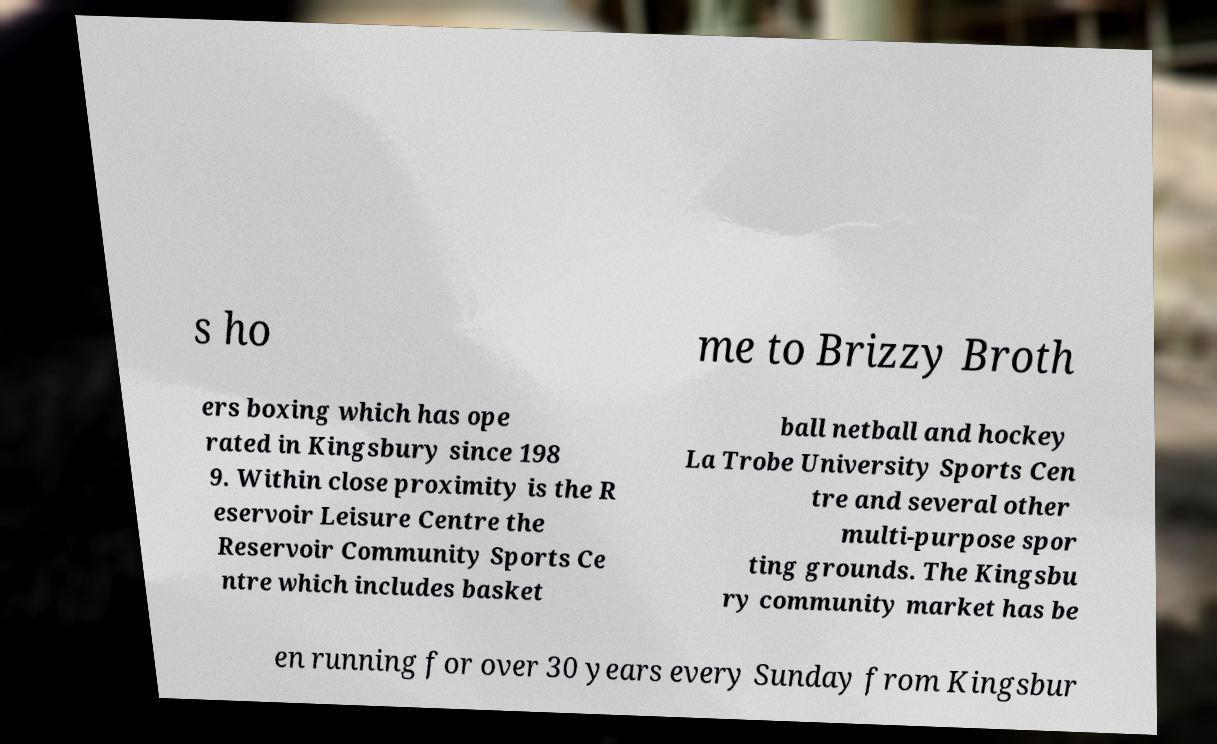I need the written content from this picture converted into text. Can you do that? s ho me to Brizzy Broth ers boxing which has ope rated in Kingsbury since 198 9. Within close proximity is the R eservoir Leisure Centre the Reservoir Community Sports Ce ntre which includes basket ball netball and hockey La Trobe University Sports Cen tre and several other multi-purpose spor ting grounds. The Kingsbu ry community market has be en running for over 30 years every Sunday from Kingsbur 